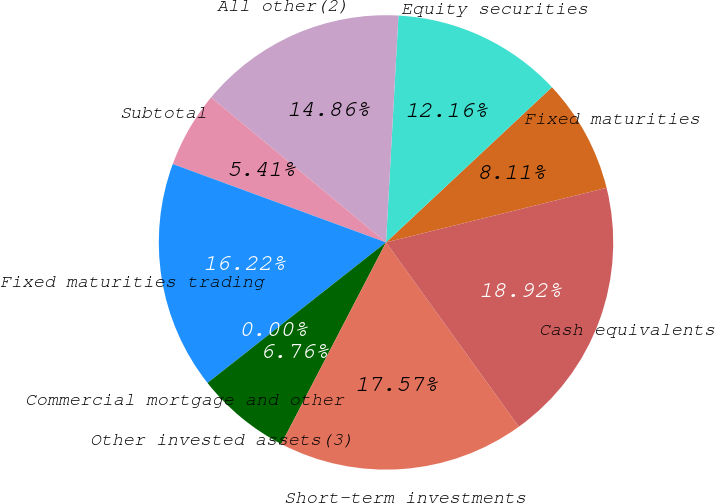Convert chart. <chart><loc_0><loc_0><loc_500><loc_500><pie_chart><fcel>Fixed maturities<fcel>Equity securities<fcel>All other(2)<fcel>Subtotal<fcel>Fixed maturities trading<fcel>Commercial mortgage and other<fcel>Other invested assets(3)<fcel>Short-term investments<fcel>Cash equivalents<nl><fcel>8.11%<fcel>12.16%<fcel>14.86%<fcel>5.41%<fcel>16.22%<fcel>0.0%<fcel>6.76%<fcel>17.57%<fcel>18.92%<nl></chart> 